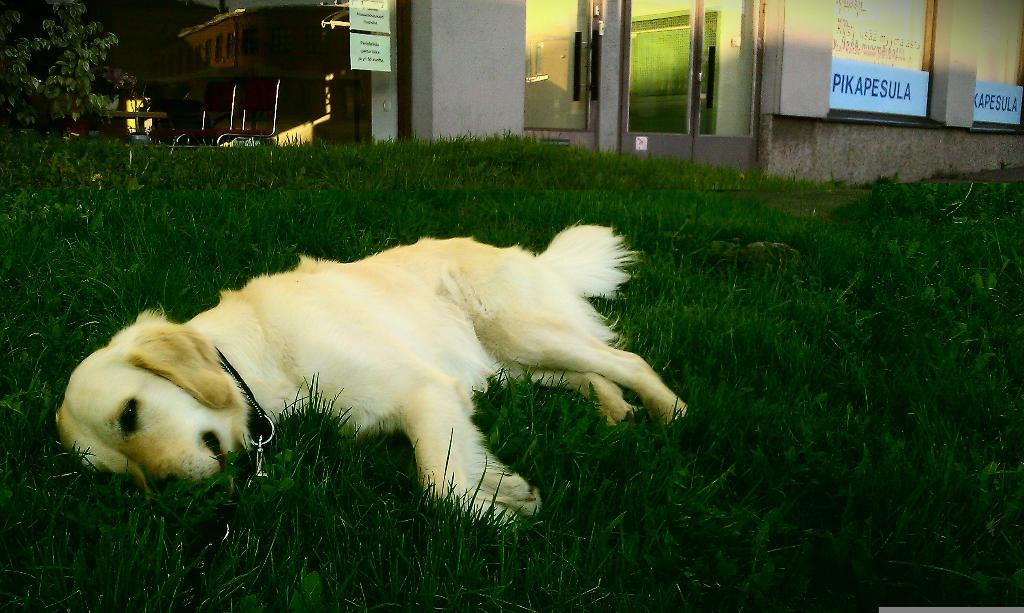Where was the image taken? The image was clicked outside. What can be seen in the middle of the image? There is grass and a dog in the middle of the image. What is visible at the top of the image? There is a building at the top of the image. What type of vegetation is present in the top left corner of the image? There are trees in the top left corner of the image. What month is the dog's owner celebrating their birthday in the image? There is no dog owner present in the image, and therefore no birthday celebration can be observed. 